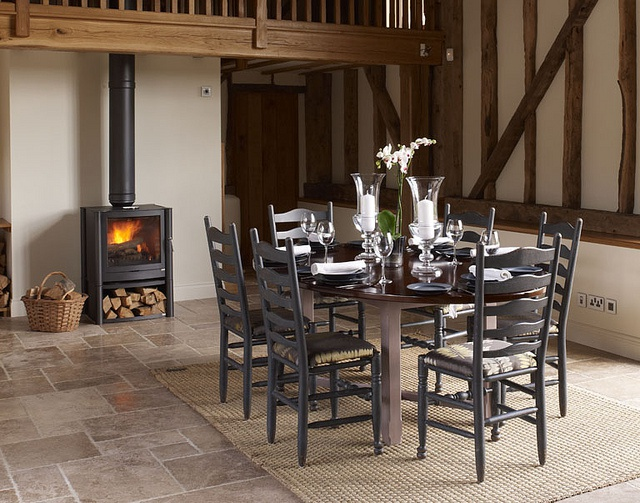Describe the objects in this image and their specific colors. I can see dining table in gray, black, lightgray, and darkgray tones, chair in gray, black, darkgray, and lightgray tones, chair in gray, black, and maroon tones, chair in gray, black, and maroon tones, and chair in gray, black, and darkgray tones in this image. 